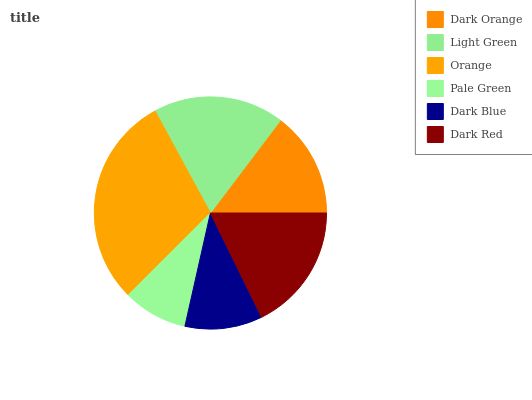Is Pale Green the minimum?
Answer yes or no. Yes. Is Orange the maximum?
Answer yes or no. Yes. Is Light Green the minimum?
Answer yes or no. No. Is Light Green the maximum?
Answer yes or no. No. Is Light Green greater than Dark Orange?
Answer yes or no. Yes. Is Dark Orange less than Light Green?
Answer yes or no. Yes. Is Dark Orange greater than Light Green?
Answer yes or no. No. Is Light Green less than Dark Orange?
Answer yes or no. No. Is Dark Red the high median?
Answer yes or no. Yes. Is Dark Orange the low median?
Answer yes or no. Yes. Is Dark Blue the high median?
Answer yes or no. No. Is Light Green the low median?
Answer yes or no. No. 